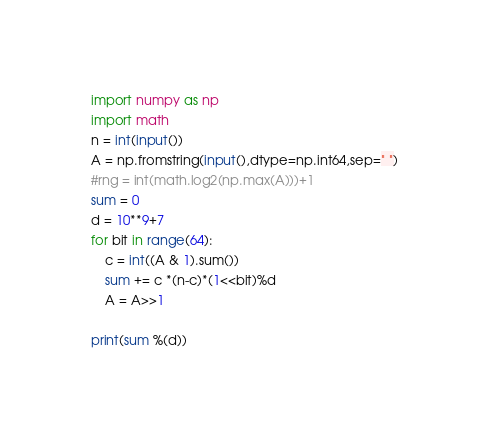Convert code to text. <code><loc_0><loc_0><loc_500><loc_500><_Python_>import numpy as np
import math
n = int(input())
A = np.fromstring(input(),dtype=np.int64,sep=" ")
#rng = int(math.log2(np.max(A)))+1
sum = 0
d = 10**9+7
for bit in range(64):
    c = int((A & 1).sum())
    sum += c *(n-c)*(1<<bit)%d
    A = A>>1

print(sum %(d))</code> 